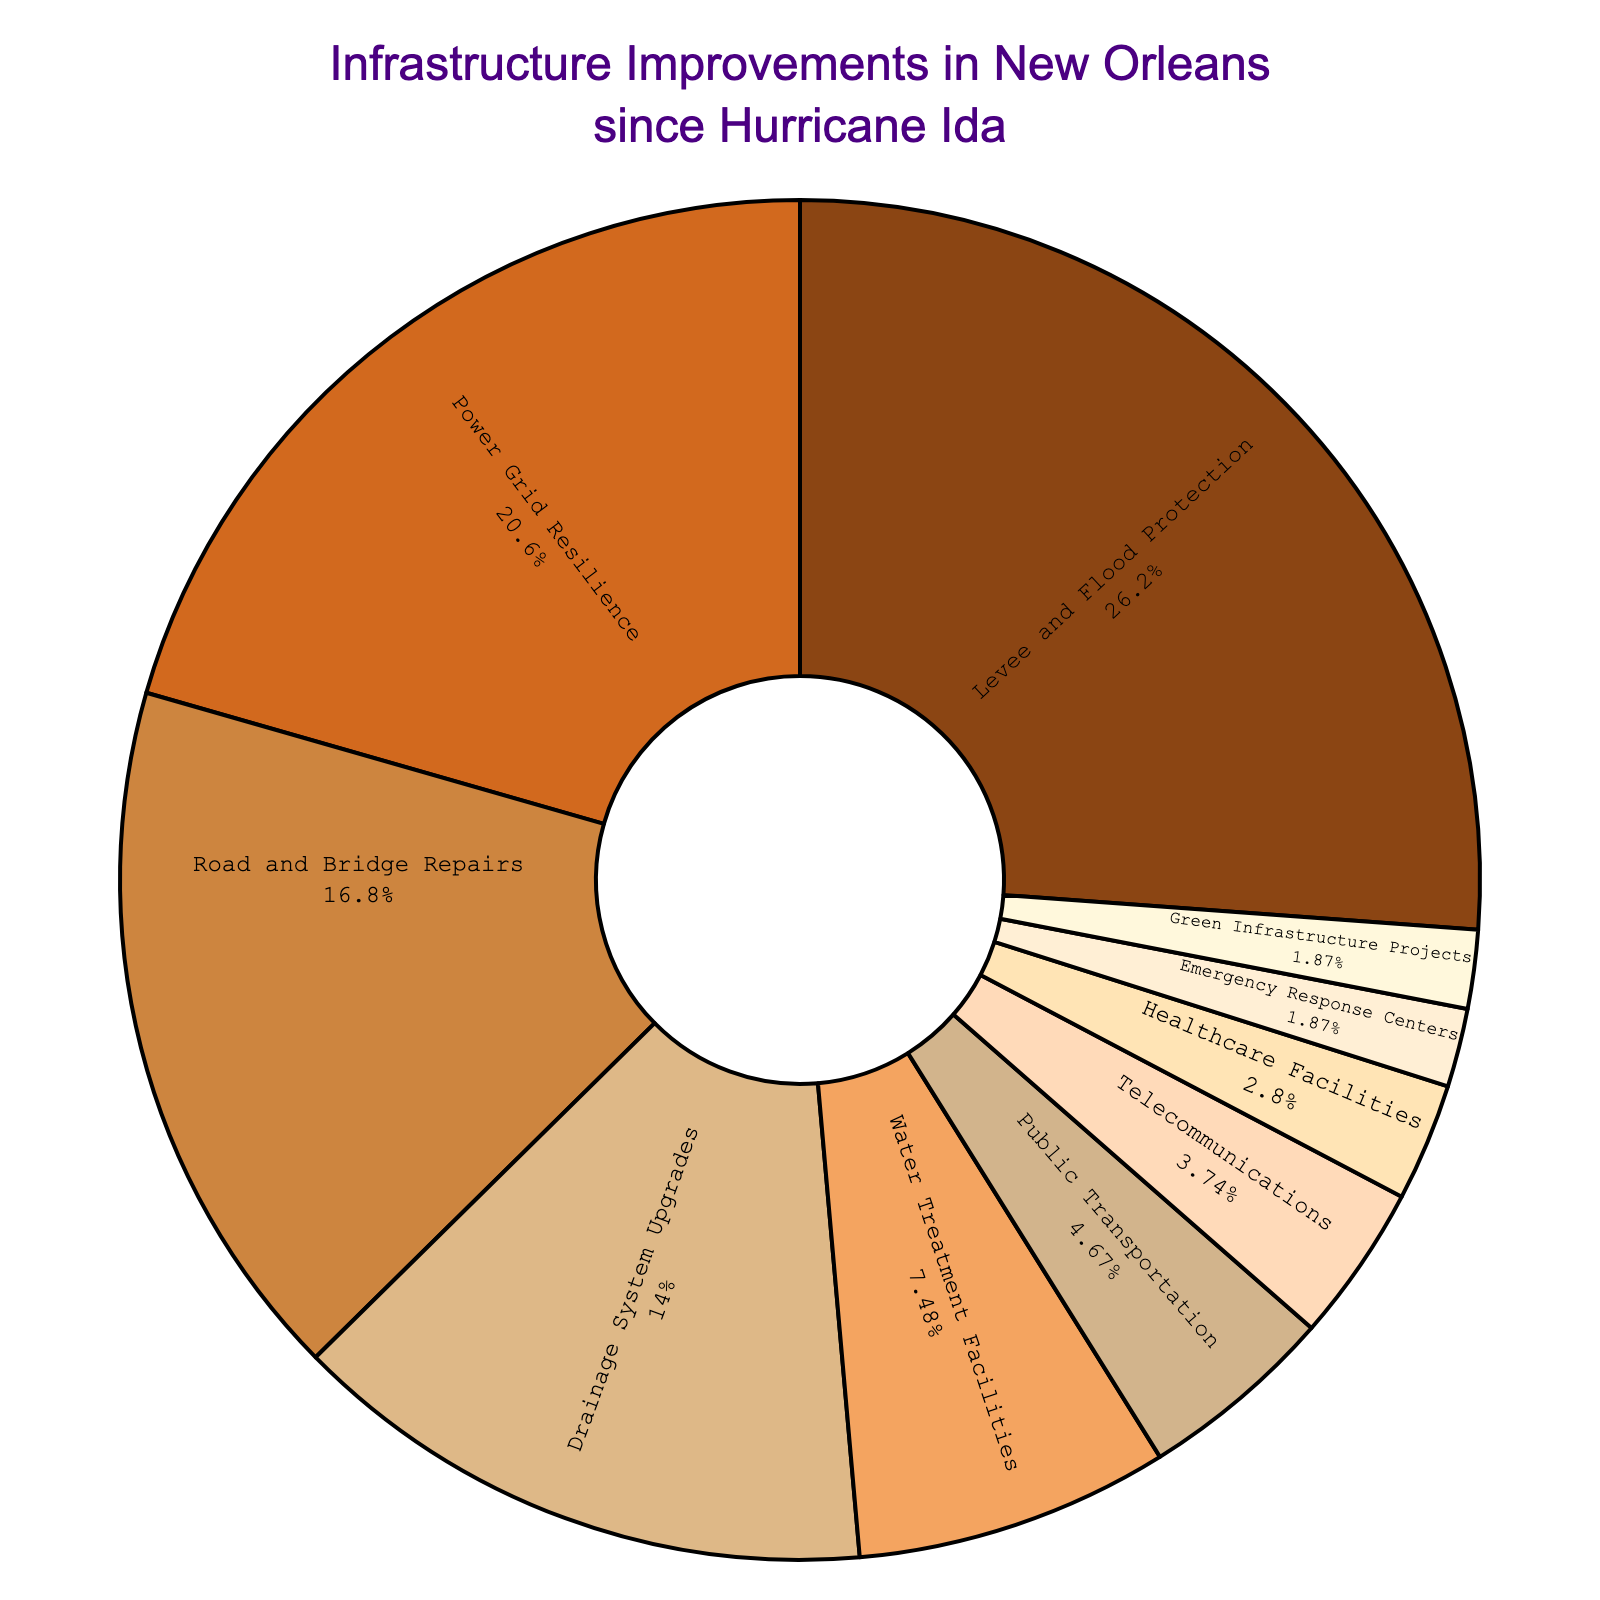Which category received the highest percentage of infrastructure improvements? The slice labeled "Levee and Flood Protection" is the largest, accounting for 28% of the total improvements.
Answer: Levee and Flood Protection What percentage was allocated to Power Grid Resilience? The labeled slice for "Power Grid Resilience" shows 22%.
Answer: 22% How does the percentage for Road and Bridge Repairs compare to Drainage System Upgrades? Road and Bridge Repairs account for 18%, while Drainage System Upgrades account for 15%. Therefore, Road and Bridge Repairs received a higher percentage.
Answer: Road and Bridge Repairs What is the combined percentage for Public Transportation and Telecommunications improvements? Public Transportation is 5% and Telecommunications is 4%. Adding these percentages together: 5% + 4% = 9%.
Answer: 9% Which categories received less than 5% of the infrastructure improvements? Categories with less than 5% are: Telecommunications (4%), Healthcare Facilities (3%), Emergency Response Centers (2%), and Green Infrastructure Projects (2%).
Answer: Telecommunications, Healthcare Facilities, Emergency Response Centers, Green Infrastructure Projects What percentage went into Green Infrastructure Projects? The labeled slice for "Green Infrastructure Projects" shows 2%.
Answer: 2% What is the difference in percentage between Water Treatment Facilities and Healthcare Facilities improvements? Water Treatment Facilities account for 8% and Healthcare Facilities account for 3%. The difference is 8% - 3% = 5%.
Answer: 5% Which category has the smallest percentage allocation, and what percentage is it? Both Emergency Response Centers and Green Infrastructure Projects are the smallest, each with 2%.
Answer: Emergency Response Centers, Green Infrastructure Projects How do the percentages of Levee and Flood Protection and Power Grid Resilience together compare to the total percentage given to the remaining categories? The combined percentage for Levee and Flood Protection (28%) and Power Grid Resilience (22%) is 28% + 22% = 50%. The total for the remaining categories is 100% - 50% = 50%, so they are equal.
Answer: Equal (50%) What is the combined percentage of the three smallest categories? The three smallest categories are Healthcare Facilities (3%), Emergency Response Centers (2%), and Green Infrastructure Projects (2%). Summing these up gives: 3% + 2% + 2% = 7%.
Answer: 7% 